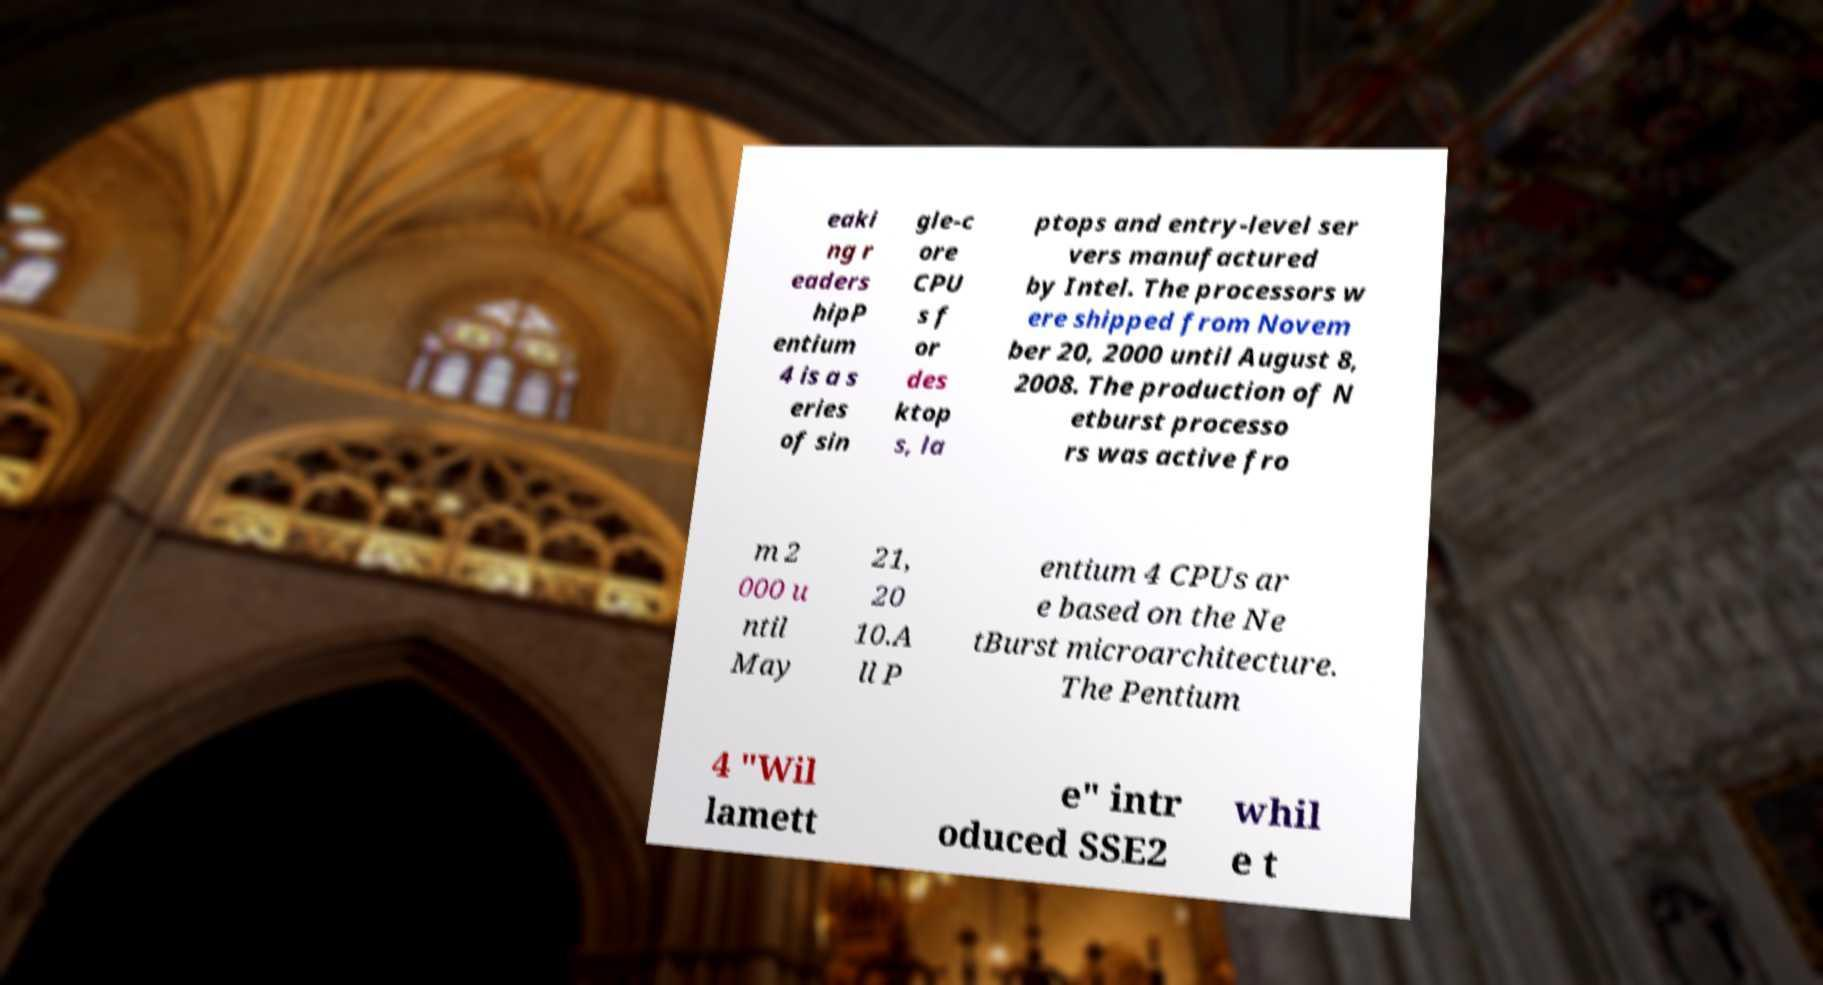Please identify and transcribe the text found in this image. eaki ng r eaders hipP entium 4 is a s eries of sin gle-c ore CPU s f or des ktop s, la ptops and entry-level ser vers manufactured by Intel. The processors w ere shipped from Novem ber 20, 2000 until August 8, 2008. The production of N etburst processo rs was active fro m 2 000 u ntil May 21, 20 10.A ll P entium 4 CPUs ar e based on the Ne tBurst microarchitecture. The Pentium 4 "Wil lamett e" intr oduced SSE2 whil e t 